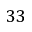<formula> <loc_0><loc_0><loc_500><loc_500>3 3</formula> 